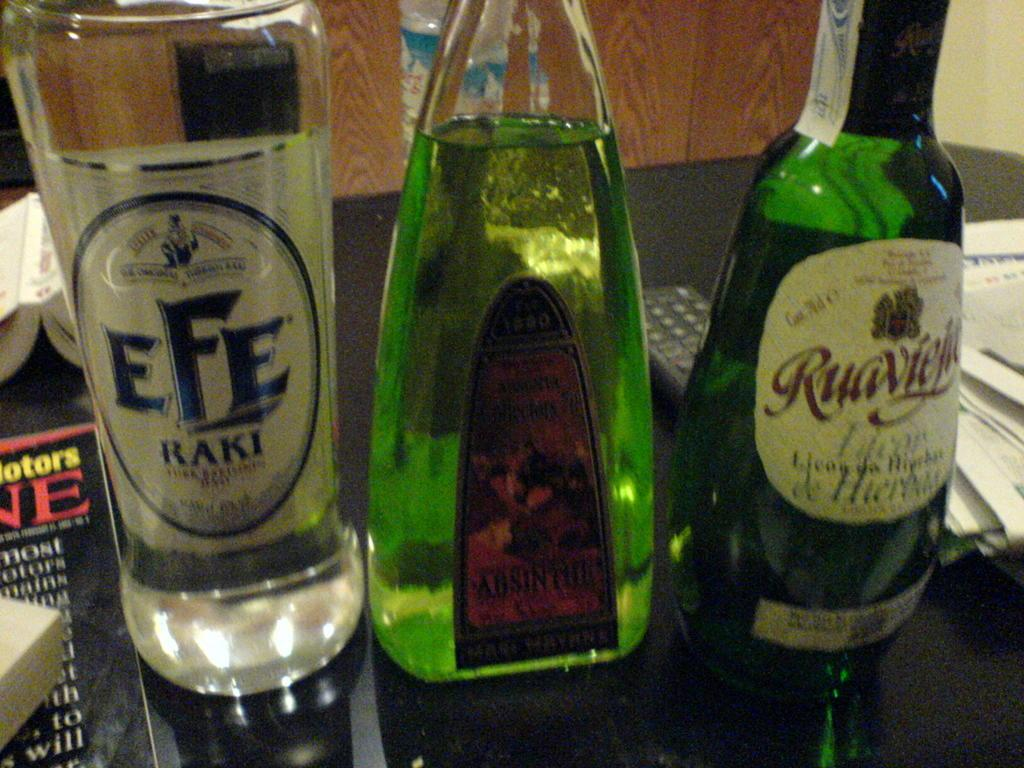How many bottles are on the table in the image? There are three bottles on the table in the image. What other items can be seen on the table? There are books, papers, and a remote on the table. What type of crayon is being used to color the berries on the cake in the image? There is no crayon, berries, or cake present in the image. 